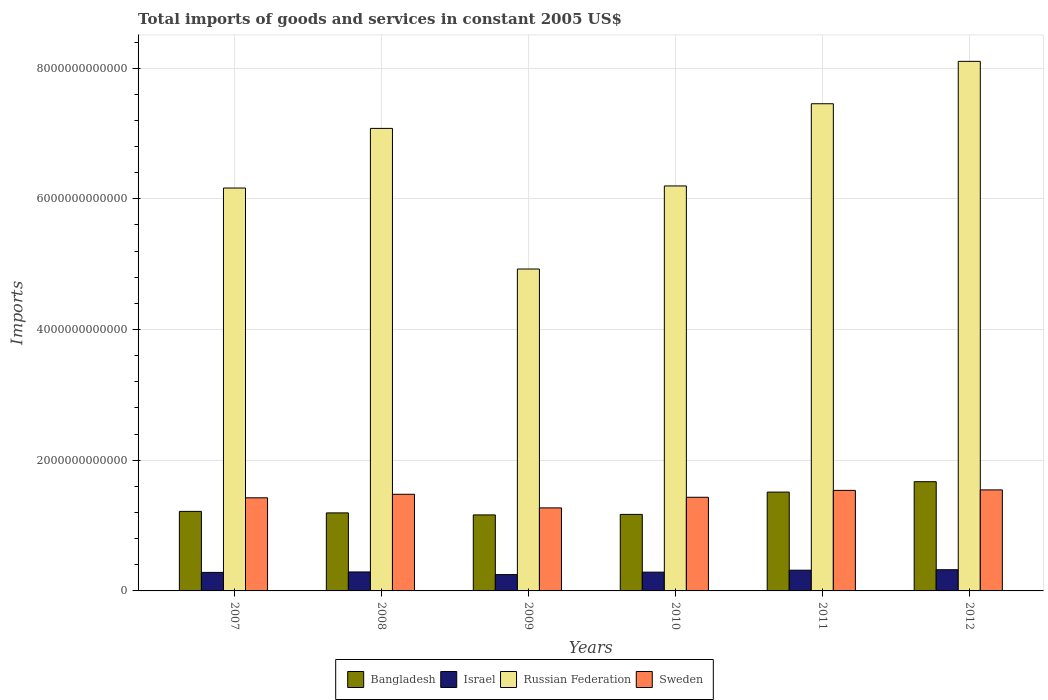How many different coloured bars are there?
Keep it short and to the point. 4. How many groups of bars are there?
Provide a short and direct response. 6. Are the number of bars on each tick of the X-axis equal?
Your response must be concise. Yes. How many bars are there on the 3rd tick from the left?
Give a very brief answer. 4. What is the label of the 5th group of bars from the left?
Provide a succinct answer. 2011. What is the total imports of goods and services in Bangladesh in 2008?
Provide a short and direct response. 1.19e+12. Across all years, what is the maximum total imports of goods and services in Sweden?
Make the answer very short. 1.55e+12. Across all years, what is the minimum total imports of goods and services in Sweden?
Your answer should be compact. 1.27e+12. In which year was the total imports of goods and services in Russian Federation maximum?
Your response must be concise. 2012. What is the total total imports of goods and services in Israel in the graph?
Give a very brief answer. 1.75e+12. What is the difference between the total imports of goods and services in Sweden in 2011 and that in 2012?
Keep it short and to the point. -7.42e+09. What is the difference between the total imports of goods and services in Sweden in 2010 and the total imports of goods and services in Russian Federation in 2009?
Give a very brief answer. -3.49e+12. What is the average total imports of goods and services in Israel per year?
Offer a terse response. 2.92e+11. In the year 2010, what is the difference between the total imports of goods and services in Bangladesh and total imports of goods and services in Israel?
Provide a succinct answer. 8.84e+11. What is the ratio of the total imports of goods and services in Israel in 2011 to that in 2012?
Make the answer very short. 0.98. Is the total imports of goods and services in Israel in 2008 less than that in 2011?
Your response must be concise. Yes. What is the difference between the highest and the second highest total imports of goods and services in Bangladesh?
Make the answer very short. 1.59e+11. What is the difference between the highest and the lowest total imports of goods and services in Israel?
Your response must be concise. 7.46e+1. In how many years, is the total imports of goods and services in Sweden greater than the average total imports of goods and services in Sweden taken over all years?
Give a very brief answer. 3. Is it the case that in every year, the sum of the total imports of goods and services in Russian Federation and total imports of goods and services in Israel is greater than the sum of total imports of goods and services in Bangladesh and total imports of goods and services in Sweden?
Make the answer very short. Yes. What does the 3rd bar from the left in 2007 represents?
Provide a short and direct response. Russian Federation. What does the 1st bar from the right in 2007 represents?
Provide a succinct answer. Sweden. Is it the case that in every year, the sum of the total imports of goods and services in Israel and total imports of goods and services in Sweden is greater than the total imports of goods and services in Bangladesh?
Offer a terse response. Yes. How many bars are there?
Offer a terse response. 24. Are all the bars in the graph horizontal?
Provide a short and direct response. No. How many years are there in the graph?
Make the answer very short. 6. What is the difference between two consecutive major ticks on the Y-axis?
Keep it short and to the point. 2.00e+12. Are the values on the major ticks of Y-axis written in scientific E-notation?
Offer a very short reply. No. How many legend labels are there?
Offer a very short reply. 4. How are the legend labels stacked?
Provide a succinct answer. Horizontal. What is the title of the graph?
Offer a terse response. Total imports of goods and services in constant 2005 US$. What is the label or title of the X-axis?
Offer a very short reply. Years. What is the label or title of the Y-axis?
Ensure brevity in your answer.  Imports. What is the Imports in Bangladesh in 2007?
Ensure brevity in your answer.  1.22e+12. What is the Imports of Israel in 2007?
Provide a short and direct response. 2.83e+11. What is the Imports in Russian Federation in 2007?
Offer a very short reply. 6.17e+12. What is the Imports of Sweden in 2007?
Keep it short and to the point. 1.43e+12. What is the Imports in Bangladesh in 2008?
Ensure brevity in your answer.  1.19e+12. What is the Imports in Israel in 2008?
Provide a short and direct response. 2.90e+11. What is the Imports of Russian Federation in 2008?
Offer a very short reply. 7.08e+12. What is the Imports in Sweden in 2008?
Ensure brevity in your answer.  1.48e+12. What is the Imports of Bangladesh in 2009?
Your answer should be very brief. 1.16e+12. What is the Imports in Israel in 2009?
Offer a very short reply. 2.50e+11. What is the Imports in Russian Federation in 2009?
Your answer should be very brief. 4.93e+12. What is the Imports in Sweden in 2009?
Give a very brief answer. 1.27e+12. What is the Imports of Bangladesh in 2010?
Offer a terse response. 1.17e+12. What is the Imports in Israel in 2010?
Offer a very short reply. 2.87e+11. What is the Imports in Russian Federation in 2010?
Your response must be concise. 6.20e+12. What is the Imports in Sweden in 2010?
Your response must be concise. 1.43e+12. What is the Imports of Bangladesh in 2011?
Your answer should be compact. 1.51e+12. What is the Imports of Israel in 2011?
Offer a very short reply. 3.17e+11. What is the Imports in Russian Federation in 2011?
Provide a succinct answer. 7.46e+12. What is the Imports of Sweden in 2011?
Provide a short and direct response. 1.54e+12. What is the Imports in Bangladesh in 2012?
Provide a short and direct response. 1.67e+12. What is the Imports of Israel in 2012?
Provide a succinct answer. 3.24e+11. What is the Imports of Russian Federation in 2012?
Your answer should be compact. 8.10e+12. What is the Imports of Sweden in 2012?
Offer a terse response. 1.55e+12. Across all years, what is the maximum Imports of Bangladesh?
Give a very brief answer. 1.67e+12. Across all years, what is the maximum Imports of Israel?
Ensure brevity in your answer.  3.24e+11. Across all years, what is the maximum Imports of Russian Federation?
Provide a succinct answer. 8.10e+12. Across all years, what is the maximum Imports in Sweden?
Offer a terse response. 1.55e+12. Across all years, what is the minimum Imports in Bangladesh?
Your response must be concise. 1.16e+12. Across all years, what is the minimum Imports in Israel?
Provide a short and direct response. 2.50e+11. Across all years, what is the minimum Imports of Russian Federation?
Your response must be concise. 4.93e+12. Across all years, what is the minimum Imports of Sweden?
Keep it short and to the point. 1.27e+12. What is the total Imports in Bangladesh in the graph?
Make the answer very short. 7.93e+12. What is the total Imports of Israel in the graph?
Your answer should be very brief. 1.75e+12. What is the total Imports of Russian Federation in the graph?
Ensure brevity in your answer.  3.99e+13. What is the total Imports of Sweden in the graph?
Your answer should be compact. 8.69e+12. What is the difference between the Imports in Bangladesh in 2007 and that in 2008?
Make the answer very short. 2.31e+1. What is the difference between the Imports of Israel in 2007 and that in 2008?
Your response must be concise. -6.93e+09. What is the difference between the Imports of Russian Federation in 2007 and that in 2008?
Your answer should be compact. -9.13e+11. What is the difference between the Imports of Sweden in 2007 and that in 2008?
Your response must be concise. -5.40e+1. What is the difference between the Imports of Bangladesh in 2007 and that in 2009?
Ensure brevity in your answer.  5.42e+1. What is the difference between the Imports of Israel in 2007 and that in 2009?
Give a very brief answer. 3.36e+1. What is the difference between the Imports of Russian Federation in 2007 and that in 2009?
Your answer should be very brief. 1.24e+12. What is the difference between the Imports of Sweden in 2007 and that in 2009?
Offer a terse response. 1.54e+11. What is the difference between the Imports in Bangladesh in 2007 and that in 2010?
Offer a terse response. 4.62e+1. What is the difference between the Imports of Israel in 2007 and that in 2010?
Provide a short and direct response. -3.93e+09. What is the difference between the Imports in Russian Federation in 2007 and that in 2010?
Provide a succinct answer. -3.18e+1. What is the difference between the Imports of Sweden in 2007 and that in 2010?
Provide a succinct answer. -8.20e+09. What is the difference between the Imports of Bangladesh in 2007 and that in 2011?
Ensure brevity in your answer.  -2.95e+11. What is the difference between the Imports in Israel in 2007 and that in 2011?
Offer a terse response. -3.38e+1. What is the difference between the Imports in Russian Federation in 2007 and that in 2011?
Offer a terse response. -1.29e+12. What is the difference between the Imports of Sweden in 2007 and that in 2011?
Ensure brevity in your answer.  -1.13e+11. What is the difference between the Imports of Bangladesh in 2007 and that in 2012?
Provide a succinct answer. -4.54e+11. What is the difference between the Imports in Israel in 2007 and that in 2012?
Ensure brevity in your answer.  -4.10e+1. What is the difference between the Imports of Russian Federation in 2007 and that in 2012?
Provide a short and direct response. -1.94e+12. What is the difference between the Imports of Sweden in 2007 and that in 2012?
Your response must be concise. -1.21e+11. What is the difference between the Imports in Bangladesh in 2008 and that in 2009?
Give a very brief answer. 3.10e+1. What is the difference between the Imports in Israel in 2008 and that in 2009?
Keep it short and to the point. 4.05e+1. What is the difference between the Imports in Russian Federation in 2008 and that in 2009?
Your response must be concise. 2.15e+12. What is the difference between the Imports in Sweden in 2008 and that in 2009?
Your answer should be compact. 2.08e+11. What is the difference between the Imports in Bangladesh in 2008 and that in 2010?
Offer a very short reply. 2.31e+1. What is the difference between the Imports in Israel in 2008 and that in 2010?
Provide a short and direct response. 2.99e+09. What is the difference between the Imports of Russian Federation in 2008 and that in 2010?
Your answer should be compact. 8.81e+11. What is the difference between the Imports of Sweden in 2008 and that in 2010?
Make the answer very short. 4.58e+1. What is the difference between the Imports of Bangladesh in 2008 and that in 2011?
Your response must be concise. -3.18e+11. What is the difference between the Imports of Israel in 2008 and that in 2011?
Give a very brief answer. -2.69e+1. What is the difference between the Imports of Russian Federation in 2008 and that in 2011?
Offer a very short reply. -3.77e+11. What is the difference between the Imports in Sweden in 2008 and that in 2011?
Give a very brief answer. -5.94e+1. What is the difference between the Imports of Bangladesh in 2008 and that in 2012?
Provide a short and direct response. -4.77e+11. What is the difference between the Imports of Israel in 2008 and that in 2012?
Ensure brevity in your answer.  -3.41e+1. What is the difference between the Imports in Russian Federation in 2008 and that in 2012?
Provide a short and direct response. -1.03e+12. What is the difference between the Imports in Sweden in 2008 and that in 2012?
Offer a terse response. -6.68e+1. What is the difference between the Imports in Bangladesh in 2009 and that in 2010?
Make the answer very short. -7.98e+09. What is the difference between the Imports of Israel in 2009 and that in 2010?
Your answer should be very brief. -3.75e+1. What is the difference between the Imports of Russian Federation in 2009 and that in 2010?
Provide a succinct answer. -1.27e+12. What is the difference between the Imports of Sweden in 2009 and that in 2010?
Keep it short and to the point. -1.62e+11. What is the difference between the Imports of Bangladesh in 2009 and that in 2011?
Give a very brief answer. -3.49e+11. What is the difference between the Imports of Israel in 2009 and that in 2011?
Your answer should be very brief. -6.74e+1. What is the difference between the Imports of Russian Federation in 2009 and that in 2011?
Offer a terse response. -2.53e+12. What is the difference between the Imports in Sweden in 2009 and that in 2011?
Keep it short and to the point. -2.68e+11. What is the difference between the Imports of Bangladesh in 2009 and that in 2012?
Your response must be concise. -5.08e+11. What is the difference between the Imports of Israel in 2009 and that in 2012?
Provide a short and direct response. -7.46e+1. What is the difference between the Imports in Russian Federation in 2009 and that in 2012?
Give a very brief answer. -3.18e+12. What is the difference between the Imports in Sweden in 2009 and that in 2012?
Your response must be concise. -2.75e+11. What is the difference between the Imports in Bangladesh in 2010 and that in 2011?
Make the answer very short. -3.41e+11. What is the difference between the Imports in Israel in 2010 and that in 2011?
Give a very brief answer. -2.99e+1. What is the difference between the Imports in Russian Federation in 2010 and that in 2011?
Offer a terse response. -1.26e+12. What is the difference between the Imports in Sweden in 2010 and that in 2011?
Offer a very short reply. -1.05e+11. What is the difference between the Imports of Bangladesh in 2010 and that in 2012?
Offer a very short reply. -5.00e+11. What is the difference between the Imports in Israel in 2010 and that in 2012?
Provide a short and direct response. -3.71e+1. What is the difference between the Imports in Russian Federation in 2010 and that in 2012?
Offer a very short reply. -1.91e+12. What is the difference between the Imports of Sweden in 2010 and that in 2012?
Ensure brevity in your answer.  -1.13e+11. What is the difference between the Imports of Bangladesh in 2011 and that in 2012?
Provide a short and direct response. -1.59e+11. What is the difference between the Imports in Israel in 2011 and that in 2012?
Provide a short and direct response. -7.21e+09. What is the difference between the Imports in Russian Federation in 2011 and that in 2012?
Your answer should be compact. -6.49e+11. What is the difference between the Imports in Sweden in 2011 and that in 2012?
Your answer should be very brief. -7.42e+09. What is the difference between the Imports of Bangladesh in 2007 and the Imports of Israel in 2008?
Give a very brief answer. 9.27e+11. What is the difference between the Imports in Bangladesh in 2007 and the Imports in Russian Federation in 2008?
Provide a succinct answer. -5.86e+12. What is the difference between the Imports of Bangladesh in 2007 and the Imports of Sweden in 2008?
Offer a terse response. -2.62e+11. What is the difference between the Imports of Israel in 2007 and the Imports of Russian Federation in 2008?
Offer a very short reply. -6.79e+12. What is the difference between the Imports in Israel in 2007 and the Imports in Sweden in 2008?
Provide a succinct answer. -1.20e+12. What is the difference between the Imports of Russian Federation in 2007 and the Imports of Sweden in 2008?
Your response must be concise. 4.69e+12. What is the difference between the Imports of Bangladesh in 2007 and the Imports of Israel in 2009?
Provide a short and direct response. 9.67e+11. What is the difference between the Imports of Bangladesh in 2007 and the Imports of Russian Federation in 2009?
Provide a succinct answer. -3.71e+12. What is the difference between the Imports of Bangladesh in 2007 and the Imports of Sweden in 2009?
Keep it short and to the point. -5.36e+1. What is the difference between the Imports of Israel in 2007 and the Imports of Russian Federation in 2009?
Your answer should be compact. -4.64e+12. What is the difference between the Imports in Israel in 2007 and the Imports in Sweden in 2009?
Keep it short and to the point. -9.87e+11. What is the difference between the Imports of Russian Federation in 2007 and the Imports of Sweden in 2009?
Give a very brief answer. 4.89e+12. What is the difference between the Imports of Bangladesh in 2007 and the Imports of Israel in 2010?
Your answer should be compact. 9.30e+11. What is the difference between the Imports of Bangladesh in 2007 and the Imports of Russian Federation in 2010?
Make the answer very short. -4.98e+12. What is the difference between the Imports in Bangladesh in 2007 and the Imports in Sweden in 2010?
Offer a very short reply. -2.16e+11. What is the difference between the Imports in Israel in 2007 and the Imports in Russian Federation in 2010?
Your answer should be very brief. -5.91e+12. What is the difference between the Imports of Israel in 2007 and the Imports of Sweden in 2010?
Provide a short and direct response. -1.15e+12. What is the difference between the Imports in Russian Federation in 2007 and the Imports in Sweden in 2010?
Provide a succinct answer. 4.73e+12. What is the difference between the Imports in Bangladesh in 2007 and the Imports in Israel in 2011?
Offer a terse response. 9.00e+11. What is the difference between the Imports in Bangladesh in 2007 and the Imports in Russian Federation in 2011?
Your answer should be compact. -6.24e+12. What is the difference between the Imports in Bangladesh in 2007 and the Imports in Sweden in 2011?
Provide a short and direct response. -3.21e+11. What is the difference between the Imports of Israel in 2007 and the Imports of Russian Federation in 2011?
Your answer should be compact. -7.17e+12. What is the difference between the Imports of Israel in 2007 and the Imports of Sweden in 2011?
Provide a succinct answer. -1.26e+12. What is the difference between the Imports in Russian Federation in 2007 and the Imports in Sweden in 2011?
Your answer should be very brief. 4.63e+12. What is the difference between the Imports in Bangladesh in 2007 and the Imports in Israel in 2012?
Keep it short and to the point. 8.93e+11. What is the difference between the Imports of Bangladesh in 2007 and the Imports of Russian Federation in 2012?
Provide a succinct answer. -6.89e+12. What is the difference between the Imports in Bangladesh in 2007 and the Imports in Sweden in 2012?
Your answer should be very brief. -3.29e+11. What is the difference between the Imports of Israel in 2007 and the Imports of Russian Federation in 2012?
Provide a short and direct response. -7.82e+12. What is the difference between the Imports of Israel in 2007 and the Imports of Sweden in 2012?
Give a very brief answer. -1.26e+12. What is the difference between the Imports in Russian Federation in 2007 and the Imports in Sweden in 2012?
Provide a succinct answer. 4.62e+12. What is the difference between the Imports in Bangladesh in 2008 and the Imports in Israel in 2009?
Make the answer very short. 9.44e+11. What is the difference between the Imports in Bangladesh in 2008 and the Imports in Russian Federation in 2009?
Offer a very short reply. -3.73e+12. What is the difference between the Imports in Bangladesh in 2008 and the Imports in Sweden in 2009?
Your answer should be very brief. -7.67e+1. What is the difference between the Imports of Israel in 2008 and the Imports of Russian Federation in 2009?
Provide a succinct answer. -4.64e+12. What is the difference between the Imports in Israel in 2008 and the Imports in Sweden in 2009?
Your answer should be very brief. -9.81e+11. What is the difference between the Imports in Russian Federation in 2008 and the Imports in Sweden in 2009?
Your answer should be compact. 5.81e+12. What is the difference between the Imports in Bangladesh in 2008 and the Imports in Israel in 2010?
Keep it short and to the point. 9.07e+11. What is the difference between the Imports of Bangladesh in 2008 and the Imports of Russian Federation in 2010?
Offer a terse response. -5.00e+12. What is the difference between the Imports of Bangladesh in 2008 and the Imports of Sweden in 2010?
Your answer should be compact. -2.39e+11. What is the difference between the Imports in Israel in 2008 and the Imports in Russian Federation in 2010?
Provide a succinct answer. -5.91e+12. What is the difference between the Imports of Israel in 2008 and the Imports of Sweden in 2010?
Give a very brief answer. -1.14e+12. What is the difference between the Imports in Russian Federation in 2008 and the Imports in Sweden in 2010?
Make the answer very short. 5.65e+12. What is the difference between the Imports in Bangladesh in 2008 and the Imports in Israel in 2011?
Give a very brief answer. 8.77e+11. What is the difference between the Imports of Bangladesh in 2008 and the Imports of Russian Federation in 2011?
Your response must be concise. -6.26e+12. What is the difference between the Imports in Bangladesh in 2008 and the Imports in Sweden in 2011?
Provide a succinct answer. -3.44e+11. What is the difference between the Imports of Israel in 2008 and the Imports of Russian Federation in 2011?
Provide a succinct answer. -7.17e+12. What is the difference between the Imports of Israel in 2008 and the Imports of Sweden in 2011?
Your answer should be very brief. -1.25e+12. What is the difference between the Imports of Russian Federation in 2008 and the Imports of Sweden in 2011?
Make the answer very short. 5.54e+12. What is the difference between the Imports in Bangladesh in 2008 and the Imports in Israel in 2012?
Offer a very short reply. 8.70e+11. What is the difference between the Imports of Bangladesh in 2008 and the Imports of Russian Federation in 2012?
Your response must be concise. -6.91e+12. What is the difference between the Imports in Bangladesh in 2008 and the Imports in Sweden in 2012?
Ensure brevity in your answer.  -3.52e+11. What is the difference between the Imports of Israel in 2008 and the Imports of Russian Federation in 2012?
Offer a terse response. -7.81e+12. What is the difference between the Imports of Israel in 2008 and the Imports of Sweden in 2012?
Give a very brief answer. -1.26e+12. What is the difference between the Imports of Russian Federation in 2008 and the Imports of Sweden in 2012?
Your response must be concise. 5.53e+12. What is the difference between the Imports in Bangladesh in 2009 and the Imports in Israel in 2010?
Make the answer very short. 8.76e+11. What is the difference between the Imports of Bangladesh in 2009 and the Imports of Russian Federation in 2010?
Ensure brevity in your answer.  -5.03e+12. What is the difference between the Imports of Bangladesh in 2009 and the Imports of Sweden in 2010?
Give a very brief answer. -2.70e+11. What is the difference between the Imports of Israel in 2009 and the Imports of Russian Federation in 2010?
Give a very brief answer. -5.95e+12. What is the difference between the Imports of Israel in 2009 and the Imports of Sweden in 2010?
Offer a terse response. -1.18e+12. What is the difference between the Imports of Russian Federation in 2009 and the Imports of Sweden in 2010?
Make the answer very short. 3.49e+12. What is the difference between the Imports in Bangladesh in 2009 and the Imports in Israel in 2011?
Keep it short and to the point. 8.46e+11. What is the difference between the Imports in Bangladesh in 2009 and the Imports in Russian Federation in 2011?
Provide a short and direct response. -6.29e+12. What is the difference between the Imports of Bangladesh in 2009 and the Imports of Sweden in 2011?
Your answer should be compact. -3.75e+11. What is the difference between the Imports in Israel in 2009 and the Imports in Russian Federation in 2011?
Keep it short and to the point. -7.21e+12. What is the difference between the Imports in Israel in 2009 and the Imports in Sweden in 2011?
Make the answer very short. -1.29e+12. What is the difference between the Imports in Russian Federation in 2009 and the Imports in Sweden in 2011?
Your answer should be very brief. 3.39e+12. What is the difference between the Imports in Bangladesh in 2009 and the Imports in Israel in 2012?
Provide a succinct answer. 8.39e+11. What is the difference between the Imports of Bangladesh in 2009 and the Imports of Russian Federation in 2012?
Provide a succinct answer. -6.94e+12. What is the difference between the Imports in Bangladesh in 2009 and the Imports in Sweden in 2012?
Your answer should be compact. -3.83e+11. What is the difference between the Imports of Israel in 2009 and the Imports of Russian Federation in 2012?
Provide a succinct answer. -7.85e+12. What is the difference between the Imports in Israel in 2009 and the Imports in Sweden in 2012?
Provide a short and direct response. -1.30e+12. What is the difference between the Imports of Russian Federation in 2009 and the Imports of Sweden in 2012?
Your response must be concise. 3.38e+12. What is the difference between the Imports in Bangladesh in 2010 and the Imports in Israel in 2011?
Make the answer very short. 8.54e+11. What is the difference between the Imports of Bangladesh in 2010 and the Imports of Russian Federation in 2011?
Keep it short and to the point. -6.28e+12. What is the difference between the Imports in Bangladesh in 2010 and the Imports in Sweden in 2011?
Offer a very short reply. -3.67e+11. What is the difference between the Imports in Israel in 2010 and the Imports in Russian Federation in 2011?
Keep it short and to the point. -7.17e+12. What is the difference between the Imports in Israel in 2010 and the Imports in Sweden in 2011?
Ensure brevity in your answer.  -1.25e+12. What is the difference between the Imports of Russian Federation in 2010 and the Imports of Sweden in 2011?
Your answer should be very brief. 4.66e+12. What is the difference between the Imports in Bangladesh in 2010 and the Imports in Israel in 2012?
Offer a very short reply. 8.47e+11. What is the difference between the Imports of Bangladesh in 2010 and the Imports of Russian Federation in 2012?
Make the answer very short. -6.93e+12. What is the difference between the Imports of Bangladesh in 2010 and the Imports of Sweden in 2012?
Give a very brief answer. -3.75e+11. What is the difference between the Imports in Israel in 2010 and the Imports in Russian Federation in 2012?
Offer a terse response. -7.82e+12. What is the difference between the Imports in Israel in 2010 and the Imports in Sweden in 2012?
Offer a terse response. -1.26e+12. What is the difference between the Imports of Russian Federation in 2010 and the Imports of Sweden in 2012?
Provide a short and direct response. 4.65e+12. What is the difference between the Imports in Bangladesh in 2011 and the Imports in Israel in 2012?
Provide a short and direct response. 1.19e+12. What is the difference between the Imports in Bangladesh in 2011 and the Imports in Russian Federation in 2012?
Provide a short and direct response. -6.59e+12. What is the difference between the Imports of Bangladesh in 2011 and the Imports of Sweden in 2012?
Offer a terse response. -3.35e+1. What is the difference between the Imports in Israel in 2011 and the Imports in Russian Federation in 2012?
Offer a very short reply. -7.79e+12. What is the difference between the Imports in Israel in 2011 and the Imports in Sweden in 2012?
Your answer should be very brief. -1.23e+12. What is the difference between the Imports in Russian Federation in 2011 and the Imports in Sweden in 2012?
Your answer should be compact. 5.91e+12. What is the average Imports of Bangladesh per year?
Give a very brief answer. 1.32e+12. What is the average Imports of Israel per year?
Ensure brevity in your answer.  2.92e+11. What is the average Imports of Russian Federation per year?
Provide a succinct answer. 6.65e+12. What is the average Imports in Sweden per year?
Make the answer very short. 1.45e+12. In the year 2007, what is the difference between the Imports in Bangladesh and Imports in Israel?
Provide a succinct answer. 9.34e+11. In the year 2007, what is the difference between the Imports of Bangladesh and Imports of Russian Federation?
Your answer should be compact. -4.95e+12. In the year 2007, what is the difference between the Imports in Bangladesh and Imports in Sweden?
Your answer should be compact. -2.08e+11. In the year 2007, what is the difference between the Imports of Israel and Imports of Russian Federation?
Give a very brief answer. -5.88e+12. In the year 2007, what is the difference between the Imports in Israel and Imports in Sweden?
Provide a succinct answer. -1.14e+12. In the year 2007, what is the difference between the Imports of Russian Federation and Imports of Sweden?
Keep it short and to the point. 4.74e+12. In the year 2008, what is the difference between the Imports in Bangladesh and Imports in Israel?
Make the answer very short. 9.04e+11. In the year 2008, what is the difference between the Imports of Bangladesh and Imports of Russian Federation?
Give a very brief answer. -5.88e+12. In the year 2008, what is the difference between the Imports in Bangladesh and Imports in Sweden?
Your answer should be very brief. -2.85e+11. In the year 2008, what is the difference between the Imports of Israel and Imports of Russian Federation?
Give a very brief answer. -6.79e+12. In the year 2008, what is the difference between the Imports of Israel and Imports of Sweden?
Provide a succinct answer. -1.19e+12. In the year 2008, what is the difference between the Imports of Russian Federation and Imports of Sweden?
Make the answer very short. 5.60e+12. In the year 2009, what is the difference between the Imports of Bangladesh and Imports of Israel?
Your answer should be very brief. 9.13e+11. In the year 2009, what is the difference between the Imports in Bangladesh and Imports in Russian Federation?
Keep it short and to the point. -3.76e+12. In the year 2009, what is the difference between the Imports in Bangladesh and Imports in Sweden?
Offer a terse response. -1.08e+11. In the year 2009, what is the difference between the Imports in Israel and Imports in Russian Federation?
Make the answer very short. -4.68e+12. In the year 2009, what is the difference between the Imports of Israel and Imports of Sweden?
Your response must be concise. -1.02e+12. In the year 2009, what is the difference between the Imports in Russian Federation and Imports in Sweden?
Provide a short and direct response. 3.66e+12. In the year 2010, what is the difference between the Imports in Bangladesh and Imports in Israel?
Offer a very short reply. 8.84e+11. In the year 2010, what is the difference between the Imports in Bangladesh and Imports in Russian Federation?
Your answer should be compact. -5.03e+12. In the year 2010, what is the difference between the Imports of Bangladesh and Imports of Sweden?
Ensure brevity in your answer.  -2.62e+11. In the year 2010, what is the difference between the Imports in Israel and Imports in Russian Federation?
Provide a short and direct response. -5.91e+12. In the year 2010, what is the difference between the Imports of Israel and Imports of Sweden?
Provide a short and direct response. -1.15e+12. In the year 2010, what is the difference between the Imports of Russian Federation and Imports of Sweden?
Provide a succinct answer. 4.76e+12. In the year 2011, what is the difference between the Imports in Bangladesh and Imports in Israel?
Ensure brevity in your answer.  1.20e+12. In the year 2011, what is the difference between the Imports of Bangladesh and Imports of Russian Federation?
Provide a short and direct response. -5.94e+12. In the year 2011, what is the difference between the Imports of Bangladesh and Imports of Sweden?
Offer a very short reply. -2.60e+1. In the year 2011, what is the difference between the Imports of Israel and Imports of Russian Federation?
Provide a short and direct response. -7.14e+12. In the year 2011, what is the difference between the Imports of Israel and Imports of Sweden?
Your answer should be very brief. -1.22e+12. In the year 2011, what is the difference between the Imports in Russian Federation and Imports in Sweden?
Give a very brief answer. 5.92e+12. In the year 2012, what is the difference between the Imports of Bangladesh and Imports of Israel?
Keep it short and to the point. 1.35e+12. In the year 2012, what is the difference between the Imports in Bangladesh and Imports in Russian Federation?
Offer a very short reply. -6.43e+12. In the year 2012, what is the difference between the Imports in Bangladesh and Imports in Sweden?
Your response must be concise. 1.26e+11. In the year 2012, what is the difference between the Imports in Israel and Imports in Russian Federation?
Ensure brevity in your answer.  -7.78e+12. In the year 2012, what is the difference between the Imports in Israel and Imports in Sweden?
Give a very brief answer. -1.22e+12. In the year 2012, what is the difference between the Imports of Russian Federation and Imports of Sweden?
Provide a succinct answer. 6.56e+12. What is the ratio of the Imports of Bangladesh in 2007 to that in 2008?
Ensure brevity in your answer.  1.02. What is the ratio of the Imports in Israel in 2007 to that in 2008?
Make the answer very short. 0.98. What is the ratio of the Imports in Russian Federation in 2007 to that in 2008?
Your response must be concise. 0.87. What is the ratio of the Imports in Sweden in 2007 to that in 2008?
Make the answer very short. 0.96. What is the ratio of the Imports in Bangladesh in 2007 to that in 2009?
Ensure brevity in your answer.  1.05. What is the ratio of the Imports in Israel in 2007 to that in 2009?
Your answer should be very brief. 1.13. What is the ratio of the Imports of Russian Federation in 2007 to that in 2009?
Offer a terse response. 1.25. What is the ratio of the Imports of Sweden in 2007 to that in 2009?
Your response must be concise. 1.12. What is the ratio of the Imports of Bangladesh in 2007 to that in 2010?
Make the answer very short. 1.04. What is the ratio of the Imports in Israel in 2007 to that in 2010?
Provide a short and direct response. 0.99. What is the ratio of the Imports in Russian Federation in 2007 to that in 2010?
Make the answer very short. 0.99. What is the ratio of the Imports in Sweden in 2007 to that in 2010?
Make the answer very short. 0.99. What is the ratio of the Imports of Bangladesh in 2007 to that in 2011?
Provide a short and direct response. 0.8. What is the ratio of the Imports in Israel in 2007 to that in 2011?
Keep it short and to the point. 0.89. What is the ratio of the Imports in Russian Federation in 2007 to that in 2011?
Keep it short and to the point. 0.83. What is the ratio of the Imports in Sweden in 2007 to that in 2011?
Ensure brevity in your answer.  0.93. What is the ratio of the Imports of Bangladesh in 2007 to that in 2012?
Your response must be concise. 0.73. What is the ratio of the Imports of Israel in 2007 to that in 2012?
Keep it short and to the point. 0.87. What is the ratio of the Imports in Russian Federation in 2007 to that in 2012?
Make the answer very short. 0.76. What is the ratio of the Imports of Sweden in 2007 to that in 2012?
Your answer should be compact. 0.92. What is the ratio of the Imports of Bangladesh in 2008 to that in 2009?
Provide a short and direct response. 1.03. What is the ratio of the Imports in Israel in 2008 to that in 2009?
Provide a short and direct response. 1.16. What is the ratio of the Imports in Russian Federation in 2008 to that in 2009?
Your answer should be compact. 1.44. What is the ratio of the Imports in Sweden in 2008 to that in 2009?
Provide a succinct answer. 1.16. What is the ratio of the Imports of Bangladesh in 2008 to that in 2010?
Ensure brevity in your answer.  1.02. What is the ratio of the Imports of Israel in 2008 to that in 2010?
Ensure brevity in your answer.  1.01. What is the ratio of the Imports in Russian Federation in 2008 to that in 2010?
Your answer should be compact. 1.14. What is the ratio of the Imports in Sweden in 2008 to that in 2010?
Provide a succinct answer. 1.03. What is the ratio of the Imports of Bangladesh in 2008 to that in 2011?
Provide a succinct answer. 0.79. What is the ratio of the Imports of Israel in 2008 to that in 2011?
Ensure brevity in your answer.  0.92. What is the ratio of the Imports of Russian Federation in 2008 to that in 2011?
Your answer should be very brief. 0.95. What is the ratio of the Imports in Sweden in 2008 to that in 2011?
Offer a very short reply. 0.96. What is the ratio of the Imports in Bangladesh in 2008 to that in 2012?
Your answer should be very brief. 0.71. What is the ratio of the Imports of Israel in 2008 to that in 2012?
Offer a terse response. 0.89. What is the ratio of the Imports in Russian Federation in 2008 to that in 2012?
Provide a succinct answer. 0.87. What is the ratio of the Imports in Sweden in 2008 to that in 2012?
Give a very brief answer. 0.96. What is the ratio of the Imports in Israel in 2009 to that in 2010?
Ensure brevity in your answer.  0.87. What is the ratio of the Imports in Russian Federation in 2009 to that in 2010?
Make the answer very short. 0.79. What is the ratio of the Imports of Sweden in 2009 to that in 2010?
Your answer should be very brief. 0.89. What is the ratio of the Imports of Bangladesh in 2009 to that in 2011?
Give a very brief answer. 0.77. What is the ratio of the Imports in Israel in 2009 to that in 2011?
Offer a very short reply. 0.79. What is the ratio of the Imports in Russian Federation in 2009 to that in 2011?
Provide a short and direct response. 0.66. What is the ratio of the Imports in Sweden in 2009 to that in 2011?
Provide a short and direct response. 0.83. What is the ratio of the Imports in Bangladesh in 2009 to that in 2012?
Your response must be concise. 0.7. What is the ratio of the Imports of Israel in 2009 to that in 2012?
Your response must be concise. 0.77. What is the ratio of the Imports in Russian Federation in 2009 to that in 2012?
Keep it short and to the point. 0.61. What is the ratio of the Imports in Sweden in 2009 to that in 2012?
Your answer should be compact. 0.82. What is the ratio of the Imports in Bangladesh in 2010 to that in 2011?
Keep it short and to the point. 0.77. What is the ratio of the Imports in Israel in 2010 to that in 2011?
Provide a short and direct response. 0.91. What is the ratio of the Imports of Russian Federation in 2010 to that in 2011?
Offer a very short reply. 0.83. What is the ratio of the Imports of Sweden in 2010 to that in 2011?
Ensure brevity in your answer.  0.93. What is the ratio of the Imports in Bangladesh in 2010 to that in 2012?
Ensure brevity in your answer.  0.7. What is the ratio of the Imports in Israel in 2010 to that in 2012?
Offer a terse response. 0.89. What is the ratio of the Imports of Russian Federation in 2010 to that in 2012?
Your answer should be compact. 0.76. What is the ratio of the Imports in Sweden in 2010 to that in 2012?
Keep it short and to the point. 0.93. What is the ratio of the Imports in Bangladesh in 2011 to that in 2012?
Offer a very short reply. 0.9. What is the ratio of the Imports in Israel in 2011 to that in 2012?
Your answer should be compact. 0.98. What is the ratio of the Imports in Russian Federation in 2011 to that in 2012?
Keep it short and to the point. 0.92. What is the difference between the highest and the second highest Imports in Bangladesh?
Your answer should be very brief. 1.59e+11. What is the difference between the highest and the second highest Imports in Israel?
Your answer should be compact. 7.21e+09. What is the difference between the highest and the second highest Imports of Russian Federation?
Provide a succinct answer. 6.49e+11. What is the difference between the highest and the second highest Imports in Sweden?
Provide a succinct answer. 7.42e+09. What is the difference between the highest and the lowest Imports in Bangladesh?
Provide a succinct answer. 5.08e+11. What is the difference between the highest and the lowest Imports in Israel?
Provide a short and direct response. 7.46e+1. What is the difference between the highest and the lowest Imports in Russian Federation?
Your answer should be compact. 3.18e+12. What is the difference between the highest and the lowest Imports in Sweden?
Your answer should be compact. 2.75e+11. 